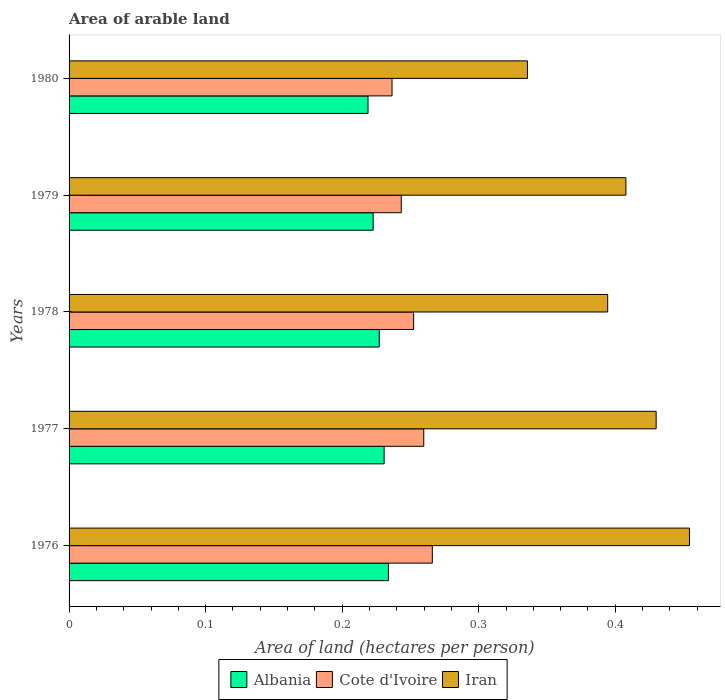How many different coloured bars are there?
Your answer should be compact. 3. How many groups of bars are there?
Offer a terse response. 5. Are the number of bars per tick equal to the number of legend labels?
Your answer should be very brief. Yes. What is the total arable land in Iran in 1976?
Offer a terse response. 0.45. Across all years, what is the maximum total arable land in Iran?
Your answer should be compact. 0.45. Across all years, what is the minimum total arable land in Albania?
Your answer should be compact. 0.22. In which year was the total arable land in Iran maximum?
Your answer should be very brief. 1976. What is the total total arable land in Iran in the graph?
Provide a short and direct response. 2.02. What is the difference between the total arable land in Cote d'Ivoire in 1977 and that in 1979?
Provide a short and direct response. 0.02. What is the difference between the total arable land in Cote d'Ivoire in 1978 and the total arable land in Iran in 1976?
Your response must be concise. -0.2. What is the average total arable land in Cote d'Ivoire per year?
Provide a short and direct response. 0.25. In the year 1976, what is the difference between the total arable land in Iran and total arable land in Cote d'Ivoire?
Your answer should be very brief. 0.19. In how many years, is the total arable land in Albania greater than 0.36000000000000004 hectares per person?
Your response must be concise. 0. What is the ratio of the total arable land in Iran in 1977 to that in 1978?
Your answer should be very brief. 1.09. Is the total arable land in Iran in 1977 less than that in 1979?
Provide a short and direct response. No. Is the difference between the total arable land in Iran in 1976 and 1979 greater than the difference between the total arable land in Cote d'Ivoire in 1976 and 1979?
Offer a terse response. Yes. What is the difference between the highest and the second highest total arable land in Iran?
Ensure brevity in your answer.  0.02. What is the difference between the highest and the lowest total arable land in Iran?
Provide a short and direct response. 0.12. Is the sum of the total arable land in Iran in 1976 and 1980 greater than the maximum total arable land in Albania across all years?
Keep it short and to the point. Yes. What does the 2nd bar from the top in 1977 represents?
Keep it short and to the point. Cote d'Ivoire. What does the 2nd bar from the bottom in 1979 represents?
Your answer should be compact. Cote d'Ivoire. Is it the case that in every year, the sum of the total arable land in Iran and total arable land in Albania is greater than the total arable land in Cote d'Ivoire?
Offer a terse response. Yes. How many years are there in the graph?
Your answer should be very brief. 5. Does the graph contain grids?
Provide a succinct answer. No. How many legend labels are there?
Keep it short and to the point. 3. What is the title of the graph?
Provide a short and direct response. Area of arable land. Does "Cyprus" appear as one of the legend labels in the graph?
Make the answer very short. No. What is the label or title of the X-axis?
Your answer should be very brief. Area of land (hectares per person). What is the Area of land (hectares per person) in Albania in 1976?
Provide a succinct answer. 0.23. What is the Area of land (hectares per person) of Cote d'Ivoire in 1976?
Your answer should be very brief. 0.27. What is the Area of land (hectares per person) in Iran in 1976?
Ensure brevity in your answer.  0.45. What is the Area of land (hectares per person) in Albania in 1977?
Your response must be concise. 0.23. What is the Area of land (hectares per person) in Cote d'Ivoire in 1977?
Make the answer very short. 0.26. What is the Area of land (hectares per person) in Iran in 1977?
Your answer should be compact. 0.43. What is the Area of land (hectares per person) of Albania in 1978?
Offer a terse response. 0.23. What is the Area of land (hectares per person) of Cote d'Ivoire in 1978?
Your answer should be very brief. 0.25. What is the Area of land (hectares per person) in Iran in 1978?
Your answer should be very brief. 0.39. What is the Area of land (hectares per person) in Albania in 1979?
Give a very brief answer. 0.22. What is the Area of land (hectares per person) in Cote d'Ivoire in 1979?
Your response must be concise. 0.24. What is the Area of land (hectares per person) of Iran in 1979?
Your answer should be very brief. 0.41. What is the Area of land (hectares per person) in Albania in 1980?
Your response must be concise. 0.22. What is the Area of land (hectares per person) of Cote d'Ivoire in 1980?
Your answer should be compact. 0.24. What is the Area of land (hectares per person) in Iran in 1980?
Provide a succinct answer. 0.34. Across all years, what is the maximum Area of land (hectares per person) of Albania?
Your answer should be compact. 0.23. Across all years, what is the maximum Area of land (hectares per person) in Cote d'Ivoire?
Offer a terse response. 0.27. Across all years, what is the maximum Area of land (hectares per person) of Iran?
Provide a succinct answer. 0.45. Across all years, what is the minimum Area of land (hectares per person) of Albania?
Your response must be concise. 0.22. Across all years, what is the minimum Area of land (hectares per person) in Cote d'Ivoire?
Offer a very short reply. 0.24. Across all years, what is the minimum Area of land (hectares per person) of Iran?
Provide a succinct answer. 0.34. What is the total Area of land (hectares per person) of Albania in the graph?
Ensure brevity in your answer.  1.13. What is the total Area of land (hectares per person) in Cote d'Ivoire in the graph?
Your answer should be very brief. 1.26. What is the total Area of land (hectares per person) of Iran in the graph?
Give a very brief answer. 2.02. What is the difference between the Area of land (hectares per person) of Albania in 1976 and that in 1977?
Provide a succinct answer. 0. What is the difference between the Area of land (hectares per person) in Cote d'Ivoire in 1976 and that in 1977?
Your answer should be very brief. 0.01. What is the difference between the Area of land (hectares per person) in Iran in 1976 and that in 1977?
Keep it short and to the point. 0.02. What is the difference between the Area of land (hectares per person) of Albania in 1976 and that in 1978?
Your answer should be compact. 0.01. What is the difference between the Area of land (hectares per person) in Cote d'Ivoire in 1976 and that in 1978?
Your answer should be compact. 0.01. What is the difference between the Area of land (hectares per person) of Iran in 1976 and that in 1978?
Offer a very short reply. 0.06. What is the difference between the Area of land (hectares per person) of Albania in 1976 and that in 1979?
Provide a succinct answer. 0.01. What is the difference between the Area of land (hectares per person) in Cote d'Ivoire in 1976 and that in 1979?
Offer a terse response. 0.02. What is the difference between the Area of land (hectares per person) of Iran in 1976 and that in 1979?
Make the answer very short. 0.05. What is the difference between the Area of land (hectares per person) of Albania in 1976 and that in 1980?
Make the answer very short. 0.01. What is the difference between the Area of land (hectares per person) of Cote d'Ivoire in 1976 and that in 1980?
Make the answer very short. 0.03. What is the difference between the Area of land (hectares per person) of Iran in 1976 and that in 1980?
Offer a terse response. 0.12. What is the difference between the Area of land (hectares per person) in Albania in 1977 and that in 1978?
Your answer should be compact. 0. What is the difference between the Area of land (hectares per person) in Cote d'Ivoire in 1977 and that in 1978?
Offer a very short reply. 0.01. What is the difference between the Area of land (hectares per person) in Iran in 1977 and that in 1978?
Provide a succinct answer. 0.04. What is the difference between the Area of land (hectares per person) of Albania in 1977 and that in 1979?
Make the answer very short. 0.01. What is the difference between the Area of land (hectares per person) of Cote d'Ivoire in 1977 and that in 1979?
Provide a succinct answer. 0.02. What is the difference between the Area of land (hectares per person) of Iran in 1977 and that in 1979?
Your response must be concise. 0.02. What is the difference between the Area of land (hectares per person) of Albania in 1977 and that in 1980?
Give a very brief answer. 0.01. What is the difference between the Area of land (hectares per person) in Cote d'Ivoire in 1977 and that in 1980?
Offer a terse response. 0.02. What is the difference between the Area of land (hectares per person) in Iran in 1977 and that in 1980?
Keep it short and to the point. 0.09. What is the difference between the Area of land (hectares per person) of Albania in 1978 and that in 1979?
Keep it short and to the point. 0. What is the difference between the Area of land (hectares per person) of Cote d'Ivoire in 1978 and that in 1979?
Your answer should be very brief. 0.01. What is the difference between the Area of land (hectares per person) in Iran in 1978 and that in 1979?
Ensure brevity in your answer.  -0.01. What is the difference between the Area of land (hectares per person) in Albania in 1978 and that in 1980?
Provide a short and direct response. 0.01. What is the difference between the Area of land (hectares per person) of Cote d'Ivoire in 1978 and that in 1980?
Keep it short and to the point. 0.02. What is the difference between the Area of land (hectares per person) of Iran in 1978 and that in 1980?
Your response must be concise. 0.06. What is the difference between the Area of land (hectares per person) in Albania in 1979 and that in 1980?
Your response must be concise. 0. What is the difference between the Area of land (hectares per person) of Cote d'Ivoire in 1979 and that in 1980?
Your answer should be very brief. 0.01. What is the difference between the Area of land (hectares per person) of Iran in 1979 and that in 1980?
Give a very brief answer. 0.07. What is the difference between the Area of land (hectares per person) of Albania in 1976 and the Area of land (hectares per person) of Cote d'Ivoire in 1977?
Your answer should be very brief. -0.03. What is the difference between the Area of land (hectares per person) of Albania in 1976 and the Area of land (hectares per person) of Iran in 1977?
Offer a terse response. -0.2. What is the difference between the Area of land (hectares per person) in Cote d'Ivoire in 1976 and the Area of land (hectares per person) in Iran in 1977?
Your answer should be very brief. -0.16. What is the difference between the Area of land (hectares per person) of Albania in 1976 and the Area of land (hectares per person) of Cote d'Ivoire in 1978?
Give a very brief answer. -0.02. What is the difference between the Area of land (hectares per person) in Albania in 1976 and the Area of land (hectares per person) in Iran in 1978?
Your answer should be compact. -0.16. What is the difference between the Area of land (hectares per person) of Cote d'Ivoire in 1976 and the Area of land (hectares per person) of Iran in 1978?
Provide a succinct answer. -0.13. What is the difference between the Area of land (hectares per person) of Albania in 1976 and the Area of land (hectares per person) of Cote d'Ivoire in 1979?
Provide a short and direct response. -0.01. What is the difference between the Area of land (hectares per person) of Albania in 1976 and the Area of land (hectares per person) of Iran in 1979?
Your answer should be compact. -0.17. What is the difference between the Area of land (hectares per person) in Cote d'Ivoire in 1976 and the Area of land (hectares per person) in Iran in 1979?
Your answer should be very brief. -0.14. What is the difference between the Area of land (hectares per person) in Albania in 1976 and the Area of land (hectares per person) in Cote d'Ivoire in 1980?
Offer a terse response. -0. What is the difference between the Area of land (hectares per person) in Albania in 1976 and the Area of land (hectares per person) in Iran in 1980?
Give a very brief answer. -0.1. What is the difference between the Area of land (hectares per person) of Cote d'Ivoire in 1976 and the Area of land (hectares per person) of Iran in 1980?
Give a very brief answer. -0.07. What is the difference between the Area of land (hectares per person) in Albania in 1977 and the Area of land (hectares per person) in Cote d'Ivoire in 1978?
Your answer should be very brief. -0.02. What is the difference between the Area of land (hectares per person) of Albania in 1977 and the Area of land (hectares per person) of Iran in 1978?
Your response must be concise. -0.16. What is the difference between the Area of land (hectares per person) of Cote d'Ivoire in 1977 and the Area of land (hectares per person) of Iran in 1978?
Make the answer very short. -0.13. What is the difference between the Area of land (hectares per person) of Albania in 1977 and the Area of land (hectares per person) of Cote d'Ivoire in 1979?
Give a very brief answer. -0.01. What is the difference between the Area of land (hectares per person) of Albania in 1977 and the Area of land (hectares per person) of Iran in 1979?
Your answer should be compact. -0.18. What is the difference between the Area of land (hectares per person) in Cote d'Ivoire in 1977 and the Area of land (hectares per person) in Iran in 1979?
Offer a very short reply. -0.15. What is the difference between the Area of land (hectares per person) of Albania in 1977 and the Area of land (hectares per person) of Cote d'Ivoire in 1980?
Your answer should be compact. -0.01. What is the difference between the Area of land (hectares per person) of Albania in 1977 and the Area of land (hectares per person) of Iran in 1980?
Your answer should be compact. -0.1. What is the difference between the Area of land (hectares per person) of Cote d'Ivoire in 1977 and the Area of land (hectares per person) of Iran in 1980?
Ensure brevity in your answer.  -0.08. What is the difference between the Area of land (hectares per person) of Albania in 1978 and the Area of land (hectares per person) of Cote d'Ivoire in 1979?
Your answer should be compact. -0.02. What is the difference between the Area of land (hectares per person) in Albania in 1978 and the Area of land (hectares per person) in Iran in 1979?
Your answer should be very brief. -0.18. What is the difference between the Area of land (hectares per person) of Cote d'Ivoire in 1978 and the Area of land (hectares per person) of Iran in 1979?
Make the answer very short. -0.16. What is the difference between the Area of land (hectares per person) in Albania in 1978 and the Area of land (hectares per person) in Cote d'Ivoire in 1980?
Provide a short and direct response. -0.01. What is the difference between the Area of land (hectares per person) in Albania in 1978 and the Area of land (hectares per person) in Iran in 1980?
Your response must be concise. -0.11. What is the difference between the Area of land (hectares per person) of Cote d'Ivoire in 1978 and the Area of land (hectares per person) of Iran in 1980?
Keep it short and to the point. -0.08. What is the difference between the Area of land (hectares per person) of Albania in 1979 and the Area of land (hectares per person) of Cote d'Ivoire in 1980?
Your answer should be very brief. -0.01. What is the difference between the Area of land (hectares per person) in Albania in 1979 and the Area of land (hectares per person) in Iran in 1980?
Give a very brief answer. -0.11. What is the difference between the Area of land (hectares per person) in Cote d'Ivoire in 1979 and the Area of land (hectares per person) in Iran in 1980?
Provide a short and direct response. -0.09. What is the average Area of land (hectares per person) of Albania per year?
Keep it short and to the point. 0.23. What is the average Area of land (hectares per person) in Cote d'Ivoire per year?
Your answer should be very brief. 0.25. What is the average Area of land (hectares per person) in Iran per year?
Offer a terse response. 0.4. In the year 1976, what is the difference between the Area of land (hectares per person) in Albania and Area of land (hectares per person) in Cote d'Ivoire?
Offer a very short reply. -0.03. In the year 1976, what is the difference between the Area of land (hectares per person) in Albania and Area of land (hectares per person) in Iran?
Your response must be concise. -0.22. In the year 1976, what is the difference between the Area of land (hectares per person) in Cote d'Ivoire and Area of land (hectares per person) in Iran?
Ensure brevity in your answer.  -0.19. In the year 1977, what is the difference between the Area of land (hectares per person) in Albania and Area of land (hectares per person) in Cote d'Ivoire?
Your answer should be very brief. -0.03. In the year 1977, what is the difference between the Area of land (hectares per person) in Albania and Area of land (hectares per person) in Iran?
Keep it short and to the point. -0.2. In the year 1977, what is the difference between the Area of land (hectares per person) in Cote d'Ivoire and Area of land (hectares per person) in Iran?
Your answer should be compact. -0.17. In the year 1978, what is the difference between the Area of land (hectares per person) in Albania and Area of land (hectares per person) in Cote d'Ivoire?
Make the answer very short. -0.03. In the year 1978, what is the difference between the Area of land (hectares per person) of Albania and Area of land (hectares per person) of Iran?
Keep it short and to the point. -0.17. In the year 1978, what is the difference between the Area of land (hectares per person) of Cote d'Ivoire and Area of land (hectares per person) of Iran?
Your response must be concise. -0.14. In the year 1979, what is the difference between the Area of land (hectares per person) of Albania and Area of land (hectares per person) of Cote d'Ivoire?
Offer a very short reply. -0.02. In the year 1979, what is the difference between the Area of land (hectares per person) of Albania and Area of land (hectares per person) of Iran?
Your answer should be very brief. -0.19. In the year 1979, what is the difference between the Area of land (hectares per person) of Cote d'Ivoire and Area of land (hectares per person) of Iran?
Your answer should be very brief. -0.16. In the year 1980, what is the difference between the Area of land (hectares per person) of Albania and Area of land (hectares per person) of Cote d'Ivoire?
Offer a very short reply. -0.02. In the year 1980, what is the difference between the Area of land (hectares per person) in Albania and Area of land (hectares per person) in Iran?
Provide a succinct answer. -0.12. In the year 1980, what is the difference between the Area of land (hectares per person) of Cote d'Ivoire and Area of land (hectares per person) of Iran?
Provide a succinct answer. -0.1. What is the ratio of the Area of land (hectares per person) of Albania in 1976 to that in 1977?
Ensure brevity in your answer.  1.01. What is the ratio of the Area of land (hectares per person) of Cote d'Ivoire in 1976 to that in 1977?
Provide a succinct answer. 1.02. What is the ratio of the Area of land (hectares per person) in Iran in 1976 to that in 1977?
Keep it short and to the point. 1.06. What is the ratio of the Area of land (hectares per person) of Albania in 1976 to that in 1978?
Provide a succinct answer. 1.03. What is the ratio of the Area of land (hectares per person) in Cote d'Ivoire in 1976 to that in 1978?
Make the answer very short. 1.05. What is the ratio of the Area of land (hectares per person) in Iran in 1976 to that in 1978?
Your answer should be compact. 1.15. What is the ratio of the Area of land (hectares per person) in Albania in 1976 to that in 1979?
Your response must be concise. 1.05. What is the ratio of the Area of land (hectares per person) in Cote d'Ivoire in 1976 to that in 1979?
Your answer should be compact. 1.09. What is the ratio of the Area of land (hectares per person) of Iran in 1976 to that in 1979?
Give a very brief answer. 1.11. What is the ratio of the Area of land (hectares per person) of Albania in 1976 to that in 1980?
Your answer should be compact. 1.07. What is the ratio of the Area of land (hectares per person) in Cote d'Ivoire in 1976 to that in 1980?
Your answer should be compact. 1.12. What is the ratio of the Area of land (hectares per person) of Iran in 1976 to that in 1980?
Provide a short and direct response. 1.35. What is the ratio of the Area of land (hectares per person) in Albania in 1977 to that in 1978?
Keep it short and to the point. 1.02. What is the ratio of the Area of land (hectares per person) in Cote d'Ivoire in 1977 to that in 1978?
Provide a succinct answer. 1.03. What is the ratio of the Area of land (hectares per person) of Iran in 1977 to that in 1978?
Ensure brevity in your answer.  1.09. What is the ratio of the Area of land (hectares per person) of Albania in 1977 to that in 1979?
Keep it short and to the point. 1.04. What is the ratio of the Area of land (hectares per person) of Cote d'Ivoire in 1977 to that in 1979?
Offer a very short reply. 1.07. What is the ratio of the Area of land (hectares per person) in Iran in 1977 to that in 1979?
Ensure brevity in your answer.  1.05. What is the ratio of the Area of land (hectares per person) in Albania in 1977 to that in 1980?
Offer a very short reply. 1.05. What is the ratio of the Area of land (hectares per person) of Cote d'Ivoire in 1977 to that in 1980?
Give a very brief answer. 1.1. What is the ratio of the Area of land (hectares per person) of Iran in 1977 to that in 1980?
Provide a succinct answer. 1.28. What is the ratio of the Area of land (hectares per person) of Albania in 1978 to that in 1979?
Your answer should be very brief. 1.02. What is the ratio of the Area of land (hectares per person) in Cote d'Ivoire in 1978 to that in 1979?
Provide a succinct answer. 1.04. What is the ratio of the Area of land (hectares per person) of Iran in 1978 to that in 1979?
Provide a succinct answer. 0.97. What is the ratio of the Area of land (hectares per person) in Albania in 1978 to that in 1980?
Keep it short and to the point. 1.04. What is the ratio of the Area of land (hectares per person) of Cote d'Ivoire in 1978 to that in 1980?
Provide a short and direct response. 1.07. What is the ratio of the Area of land (hectares per person) in Iran in 1978 to that in 1980?
Your answer should be compact. 1.18. What is the ratio of the Area of land (hectares per person) of Albania in 1979 to that in 1980?
Your answer should be compact. 1.02. What is the ratio of the Area of land (hectares per person) of Cote d'Ivoire in 1979 to that in 1980?
Offer a very short reply. 1.03. What is the ratio of the Area of land (hectares per person) in Iran in 1979 to that in 1980?
Keep it short and to the point. 1.21. What is the difference between the highest and the second highest Area of land (hectares per person) in Albania?
Provide a short and direct response. 0. What is the difference between the highest and the second highest Area of land (hectares per person) of Cote d'Ivoire?
Provide a short and direct response. 0.01. What is the difference between the highest and the second highest Area of land (hectares per person) of Iran?
Provide a succinct answer. 0.02. What is the difference between the highest and the lowest Area of land (hectares per person) in Albania?
Keep it short and to the point. 0.01. What is the difference between the highest and the lowest Area of land (hectares per person) of Cote d'Ivoire?
Your response must be concise. 0.03. What is the difference between the highest and the lowest Area of land (hectares per person) of Iran?
Offer a terse response. 0.12. 